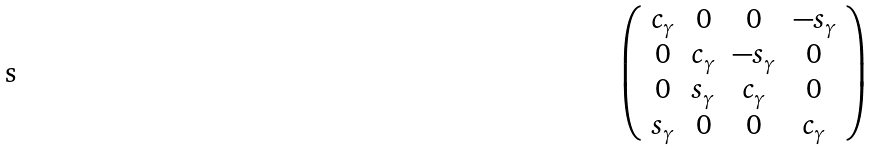Convert formula to latex. <formula><loc_0><loc_0><loc_500><loc_500>\left ( \begin{array} { c c c c } c _ { \gamma } & 0 & 0 & - s _ { \gamma } \\ 0 & c _ { \gamma } & - s _ { \gamma } & 0 \\ 0 & s _ { \gamma } & c _ { \gamma } & 0 \\ s _ { \gamma } & 0 & 0 & c _ { \gamma } \\ \end{array} \right )</formula> 